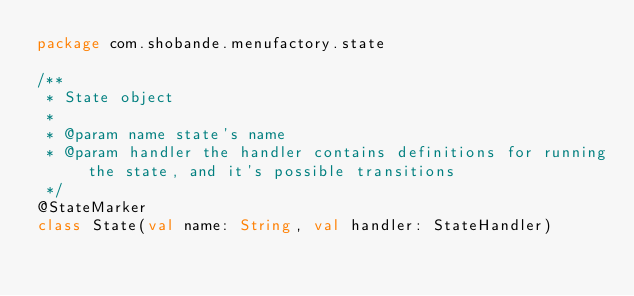Convert code to text. <code><loc_0><loc_0><loc_500><loc_500><_Kotlin_>package com.shobande.menufactory.state

/**
 * State object
 *
 * @param name state's name
 * @param handler the handler contains definitions for running the state, and it's possible transitions
 */
@StateMarker
class State(val name: String, val handler: StateHandler)</code> 